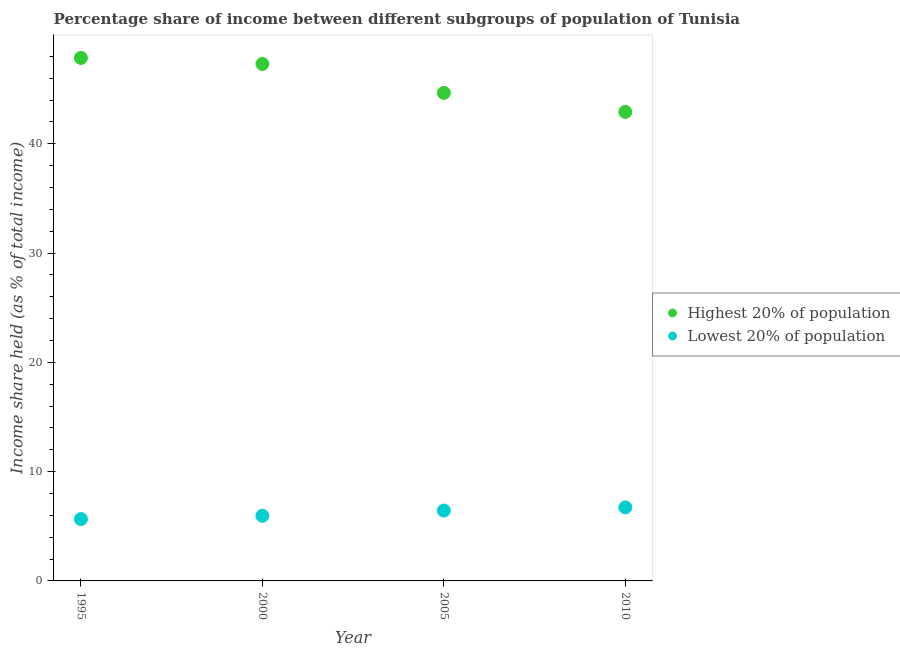Is the number of dotlines equal to the number of legend labels?
Keep it short and to the point. Yes. What is the income share held by lowest 20% of the population in 1995?
Make the answer very short. 5.66. Across all years, what is the maximum income share held by lowest 20% of the population?
Your answer should be very brief. 6.73. Across all years, what is the minimum income share held by highest 20% of the population?
Ensure brevity in your answer.  42.92. In which year was the income share held by highest 20% of the population maximum?
Your answer should be compact. 1995. What is the total income share held by highest 20% of the population in the graph?
Ensure brevity in your answer.  182.75. What is the difference between the income share held by lowest 20% of the population in 1995 and that in 2005?
Provide a short and direct response. -0.78. What is the difference between the income share held by lowest 20% of the population in 1995 and the income share held by highest 20% of the population in 2005?
Give a very brief answer. -39. What is the average income share held by highest 20% of the population per year?
Provide a succinct answer. 45.69. In the year 2005, what is the difference between the income share held by highest 20% of the population and income share held by lowest 20% of the population?
Your answer should be compact. 38.22. In how many years, is the income share held by lowest 20% of the population greater than 4 %?
Give a very brief answer. 4. What is the ratio of the income share held by highest 20% of the population in 2005 to that in 2010?
Your answer should be very brief. 1.04. Is the income share held by highest 20% of the population in 2000 less than that in 2005?
Offer a very short reply. No. What is the difference between the highest and the second highest income share held by highest 20% of the population?
Give a very brief answer. 0.55. What is the difference between the highest and the lowest income share held by lowest 20% of the population?
Offer a terse response. 1.07. Is the sum of the income share held by lowest 20% of the population in 1995 and 2005 greater than the maximum income share held by highest 20% of the population across all years?
Offer a very short reply. No. Does the income share held by highest 20% of the population monotonically increase over the years?
Your response must be concise. No. Is the income share held by highest 20% of the population strictly greater than the income share held by lowest 20% of the population over the years?
Give a very brief answer. Yes. What is the difference between two consecutive major ticks on the Y-axis?
Provide a succinct answer. 10. Does the graph contain any zero values?
Offer a terse response. No. Where does the legend appear in the graph?
Keep it short and to the point. Center right. How many legend labels are there?
Offer a very short reply. 2. How are the legend labels stacked?
Keep it short and to the point. Vertical. What is the title of the graph?
Give a very brief answer. Percentage share of income between different subgroups of population of Tunisia. Does "Total Population" appear as one of the legend labels in the graph?
Give a very brief answer. No. What is the label or title of the Y-axis?
Your answer should be very brief. Income share held (as % of total income). What is the Income share held (as % of total income) of Highest 20% of population in 1995?
Provide a short and direct response. 47.86. What is the Income share held (as % of total income) in Lowest 20% of population in 1995?
Keep it short and to the point. 5.66. What is the Income share held (as % of total income) of Highest 20% of population in 2000?
Ensure brevity in your answer.  47.31. What is the Income share held (as % of total income) of Lowest 20% of population in 2000?
Your answer should be very brief. 5.96. What is the Income share held (as % of total income) in Highest 20% of population in 2005?
Give a very brief answer. 44.66. What is the Income share held (as % of total income) of Lowest 20% of population in 2005?
Offer a terse response. 6.44. What is the Income share held (as % of total income) in Highest 20% of population in 2010?
Make the answer very short. 42.92. What is the Income share held (as % of total income) of Lowest 20% of population in 2010?
Your answer should be very brief. 6.73. Across all years, what is the maximum Income share held (as % of total income) of Highest 20% of population?
Provide a short and direct response. 47.86. Across all years, what is the maximum Income share held (as % of total income) in Lowest 20% of population?
Ensure brevity in your answer.  6.73. Across all years, what is the minimum Income share held (as % of total income) in Highest 20% of population?
Provide a succinct answer. 42.92. Across all years, what is the minimum Income share held (as % of total income) in Lowest 20% of population?
Your response must be concise. 5.66. What is the total Income share held (as % of total income) in Highest 20% of population in the graph?
Make the answer very short. 182.75. What is the total Income share held (as % of total income) in Lowest 20% of population in the graph?
Your answer should be compact. 24.79. What is the difference between the Income share held (as % of total income) of Highest 20% of population in 1995 and that in 2000?
Your response must be concise. 0.55. What is the difference between the Income share held (as % of total income) of Lowest 20% of population in 1995 and that in 2005?
Provide a succinct answer. -0.78. What is the difference between the Income share held (as % of total income) in Highest 20% of population in 1995 and that in 2010?
Ensure brevity in your answer.  4.94. What is the difference between the Income share held (as % of total income) of Lowest 20% of population in 1995 and that in 2010?
Ensure brevity in your answer.  -1.07. What is the difference between the Income share held (as % of total income) in Highest 20% of population in 2000 and that in 2005?
Your answer should be compact. 2.65. What is the difference between the Income share held (as % of total income) in Lowest 20% of population in 2000 and that in 2005?
Keep it short and to the point. -0.48. What is the difference between the Income share held (as % of total income) in Highest 20% of population in 2000 and that in 2010?
Offer a very short reply. 4.39. What is the difference between the Income share held (as % of total income) in Lowest 20% of population in 2000 and that in 2010?
Your answer should be compact. -0.77. What is the difference between the Income share held (as % of total income) of Highest 20% of population in 2005 and that in 2010?
Provide a short and direct response. 1.74. What is the difference between the Income share held (as % of total income) of Lowest 20% of population in 2005 and that in 2010?
Your answer should be compact. -0.29. What is the difference between the Income share held (as % of total income) of Highest 20% of population in 1995 and the Income share held (as % of total income) of Lowest 20% of population in 2000?
Your answer should be very brief. 41.9. What is the difference between the Income share held (as % of total income) of Highest 20% of population in 1995 and the Income share held (as % of total income) of Lowest 20% of population in 2005?
Keep it short and to the point. 41.42. What is the difference between the Income share held (as % of total income) in Highest 20% of population in 1995 and the Income share held (as % of total income) in Lowest 20% of population in 2010?
Offer a very short reply. 41.13. What is the difference between the Income share held (as % of total income) in Highest 20% of population in 2000 and the Income share held (as % of total income) in Lowest 20% of population in 2005?
Provide a short and direct response. 40.87. What is the difference between the Income share held (as % of total income) of Highest 20% of population in 2000 and the Income share held (as % of total income) of Lowest 20% of population in 2010?
Offer a very short reply. 40.58. What is the difference between the Income share held (as % of total income) in Highest 20% of population in 2005 and the Income share held (as % of total income) in Lowest 20% of population in 2010?
Provide a succinct answer. 37.93. What is the average Income share held (as % of total income) in Highest 20% of population per year?
Make the answer very short. 45.69. What is the average Income share held (as % of total income) of Lowest 20% of population per year?
Offer a very short reply. 6.2. In the year 1995, what is the difference between the Income share held (as % of total income) in Highest 20% of population and Income share held (as % of total income) in Lowest 20% of population?
Keep it short and to the point. 42.2. In the year 2000, what is the difference between the Income share held (as % of total income) of Highest 20% of population and Income share held (as % of total income) of Lowest 20% of population?
Make the answer very short. 41.35. In the year 2005, what is the difference between the Income share held (as % of total income) of Highest 20% of population and Income share held (as % of total income) of Lowest 20% of population?
Your answer should be compact. 38.22. In the year 2010, what is the difference between the Income share held (as % of total income) in Highest 20% of population and Income share held (as % of total income) in Lowest 20% of population?
Offer a terse response. 36.19. What is the ratio of the Income share held (as % of total income) in Highest 20% of population in 1995 to that in 2000?
Your answer should be compact. 1.01. What is the ratio of the Income share held (as % of total income) in Lowest 20% of population in 1995 to that in 2000?
Your answer should be very brief. 0.95. What is the ratio of the Income share held (as % of total income) in Highest 20% of population in 1995 to that in 2005?
Give a very brief answer. 1.07. What is the ratio of the Income share held (as % of total income) in Lowest 20% of population in 1995 to that in 2005?
Ensure brevity in your answer.  0.88. What is the ratio of the Income share held (as % of total income) of Highest 20% of population in 1995 to that in 2010?
Ensure brevity in your answer.  1.12. What is the ratio of the Income share held (as % of total income) in Lowest 20% of population in 1995 to that in 2010?
Keep it short and to the point. 0.84. What is the ratio of the Income share held (as % of total income) in Highest 20% of population in 2000 to that in 2005?
Ensure brevity in your answer.  1.06. What is the ratio of the Income share held (as % of total income) of Lowest 20% of population in 2000 to that in 2005?
Keep it short and to the point. 0.93. What is the ratio of the Income share held (as % of total income) of Highest 20% of population in 2000 to that in 2010?
Offer a terse response. 1.1. What is the ratio of the Income share held (as % of total income) in Lowest 20% of population in 2000 to that in 2010?
Offer a very short reply. 0.89. What is the ratio of the Income share held (as % of total income) of Highest 20% of population in 2005 to that in 2010?
Keep it short and to the point. 1.04. What is the ratio of the Income share held (as % of total income) of Lowest 20% of population in 2005 to that in 2010?
Provide a succinct answer. 0.96. What is the difference between the highest and the second highest Income share held (as % of total income) of Highest 20% of population?
Give a very brief answer. 0.55. What is the difference between the highest and the second highest Income share held (as % of total income) in Lowest 20% of population?
Your answer should be very brief. 0.29. What is the difference between the highest and the lowest Income share held (as % of total income) in Highest 20% of population?
Provide a succinct answer. 4.94. What is the difference between the highest and the lowest Income share held (as % of total income) in Lowest 20% of population?
Your answer should be very brief. 1.07. 